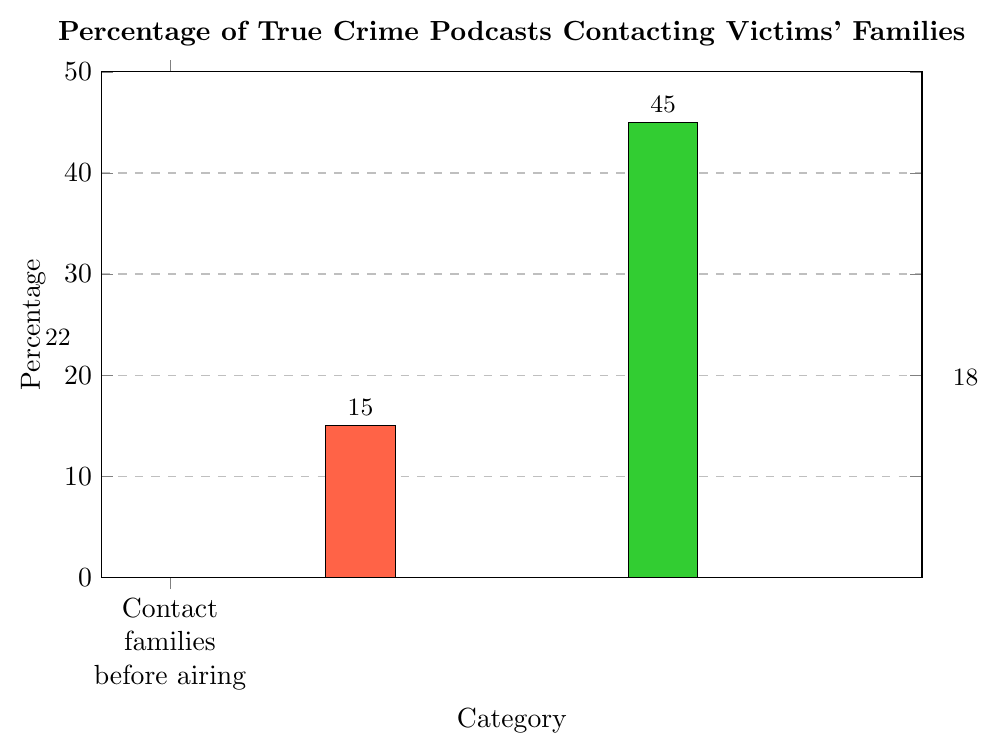Which category has the highest percentage? The bar for "Never contact families" is the tallest among all the categories, indicating it has the highest value. Thus, the "Never contact families" category has the highest percentage.
Answer: Never contact families How much more is the percentage of podcasts that never contact families compared to those that contact families before airing? The percentage for "Never contact families" is 45%, and for "Contact families before airing" is 22%. To find the difference, subtract 22% from 45%. Thus, the difference is 45% - 22% = 23%.
Answer: 23% What is the sum of the percentages for all categories? Add all the percentages: 22% (Contact families before airing) + 15% (Contact families after airing) + 45% (Never contact families) + 18% (Attempt contact but unsuccessful). The sum is 22% + 15% + 45% + 18% = 100%.
Answer: 100% What percentage of podcasts attempt to contact families (consider both successful and unsuccessful attempts)? Sum the percentages of "Contact families before airing" and "Attempt contact but unsuccessful": 22% (before airing) + 18% (unsuccessful). The combined percentage is 22% + 18% = 40%.
Answer: 40% Are there more podcasts that never contact families or those that contact families (before or after airing)? Add the percentages for contacting (before and after airing): 22% (before airing) + 15% (after airing) = 37%. Compare this with the percentage for "Never contact families" which is 45%. So, there are more podcasts that never contact families (45%) compared to those that contact families (37%).
Answer: Never contact families What is the difference between the percentages of podcasts that contact families after airing and those that attempt contact but are unsuccessful? The percentage for "Contact families after airing" is 15% and for "Attempt contact but unsuccessful" is 18%. Subtract 15% from 18% to get the difference, which is 18% - 15% = 3%.
Answer: 3% What is the average percentage of the categories excluding "Never contact families"? Add the percentages of "Contact families before airing" (22%), "Contact families after airing" (15%), and "Attempt contact but unsuccessful" (18%): 22% + 15% + 18% = 55%. Then, divide by the number of categories (3): 55% / 3 = 18.33%.
Answer: 18.33% Which category has the smallest percentage and what is its value? The shortest bar corresponds to "Contact families after airing," indicating it has the smallest percentage of 15%.
Answer: Contact families after airing, 15% What percentage of podcasts do not contact families at all, either due to not attempting or unsuccessful attempts? Add the percentages of "Never contact families" and "Attempt contact but unsuccessful": 45% (never contact) + 18% (unsuccessful attempt) = 63%.
Answer: 63% What is the difference in height between the bars representing "Attempt contact but unsuccessful" and "Contact families after airing"? The percentages are 18% for "Attempt contact but unsuccessful" and 15% for "Contact families after airing." Subtract 15% from 18% to find the difference: 18% - 15% = 3%.
Answer: 3% 